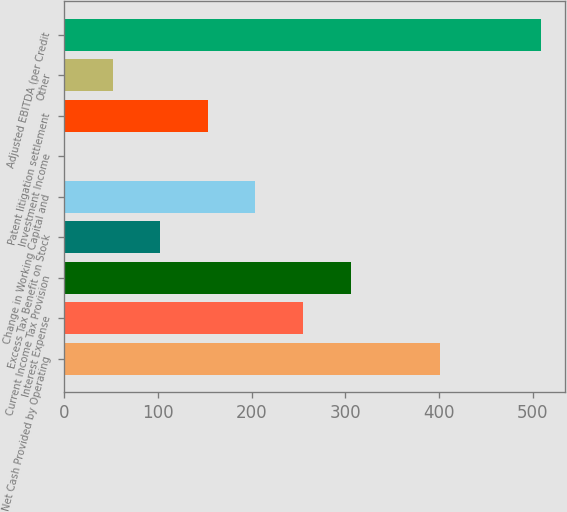Convert chart to OTSL. <chart><loc_0><loc_0><loc_500><loc_500><bar_chart><fcel>Net Cash Provided by Operating<fcel>Interest Expense<fcel>Current Income Tax Provision<fcel>Excess Tax Benefit on Stock<fcel>Change in Working Capital and<fcel>Investment Income<fcel>Patent litigation settlement<fcel>Other<fcel>Adjusted EBITDA (per Credit<nl><fcel>400.9<fcel>254.95<fcel>305.68<fcel>102.76<fcel>204.22<fcel>1.3<fcel>153.49<fcel>52.03<fcel>508.6<nl></chart> 